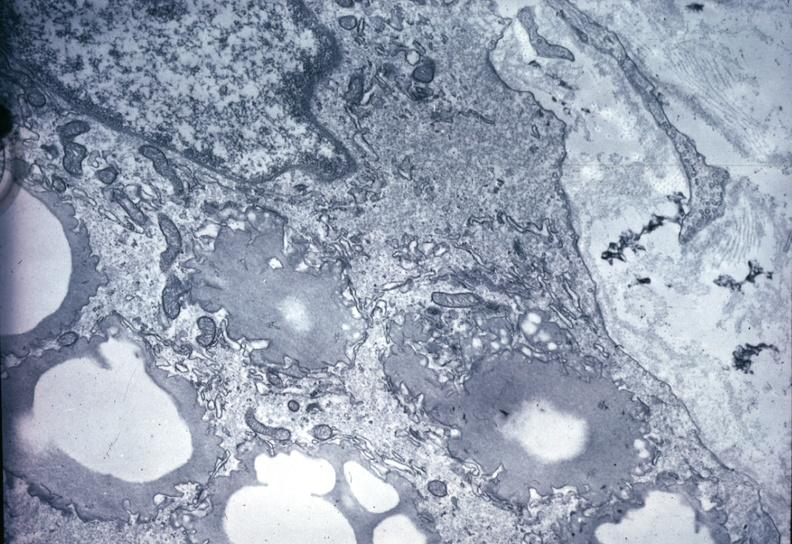s vasculature present?
Answer the question using a single word or phrase. Yes 